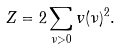<formula> <loc_0><loc_0><loc_500><loc_500>Z = 2 \sum _ { \nu > 0 } v ( \nu ) ^ { 2 } .</formula> 